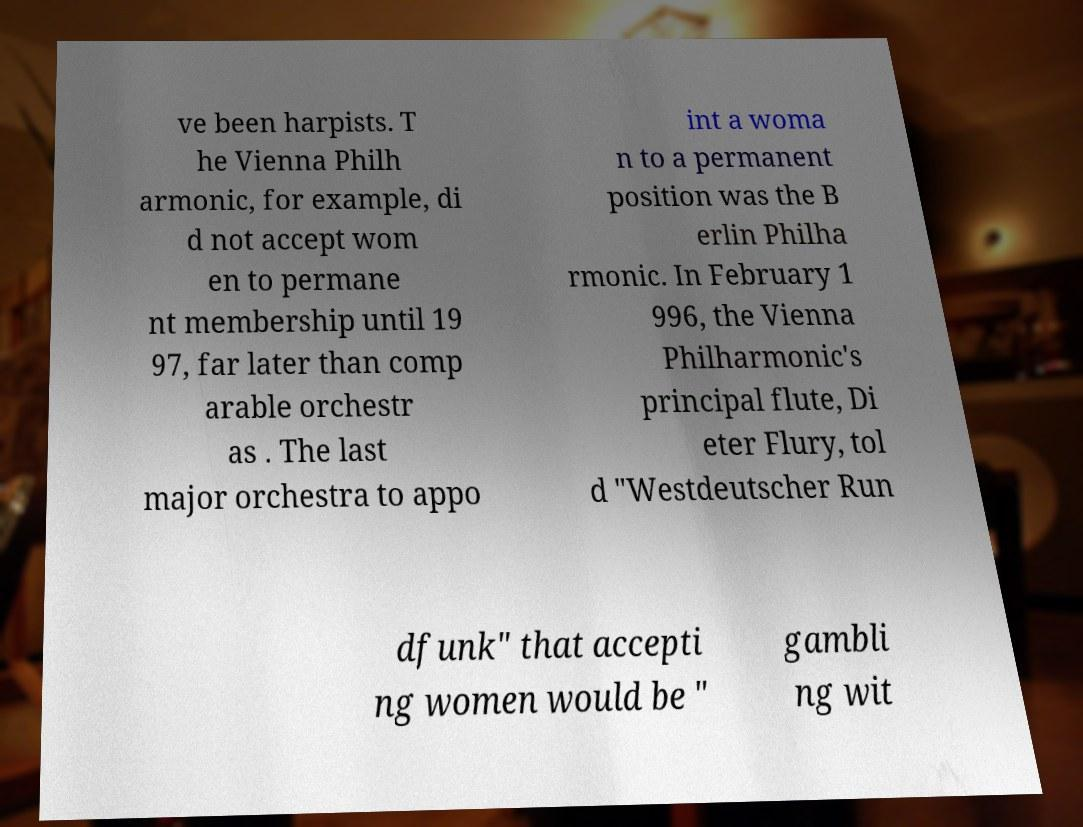Please read and relay the text visible in this image. What does it say? ve been harpists. T he Vienna Philh armonic, for example, di d not accept wom en to permane nt membership until 19 97, far later than comp arable orchestr as . The last major orchestra to appo int a woma n to a permanent position was the B erlin Philha rmonic. In February 1 996, the Vienna Philharmonic's principal flute, Di eter Flury, tol d "Westdeutscher Run dfunk" that accepti ng women would be " gambli ng wit 